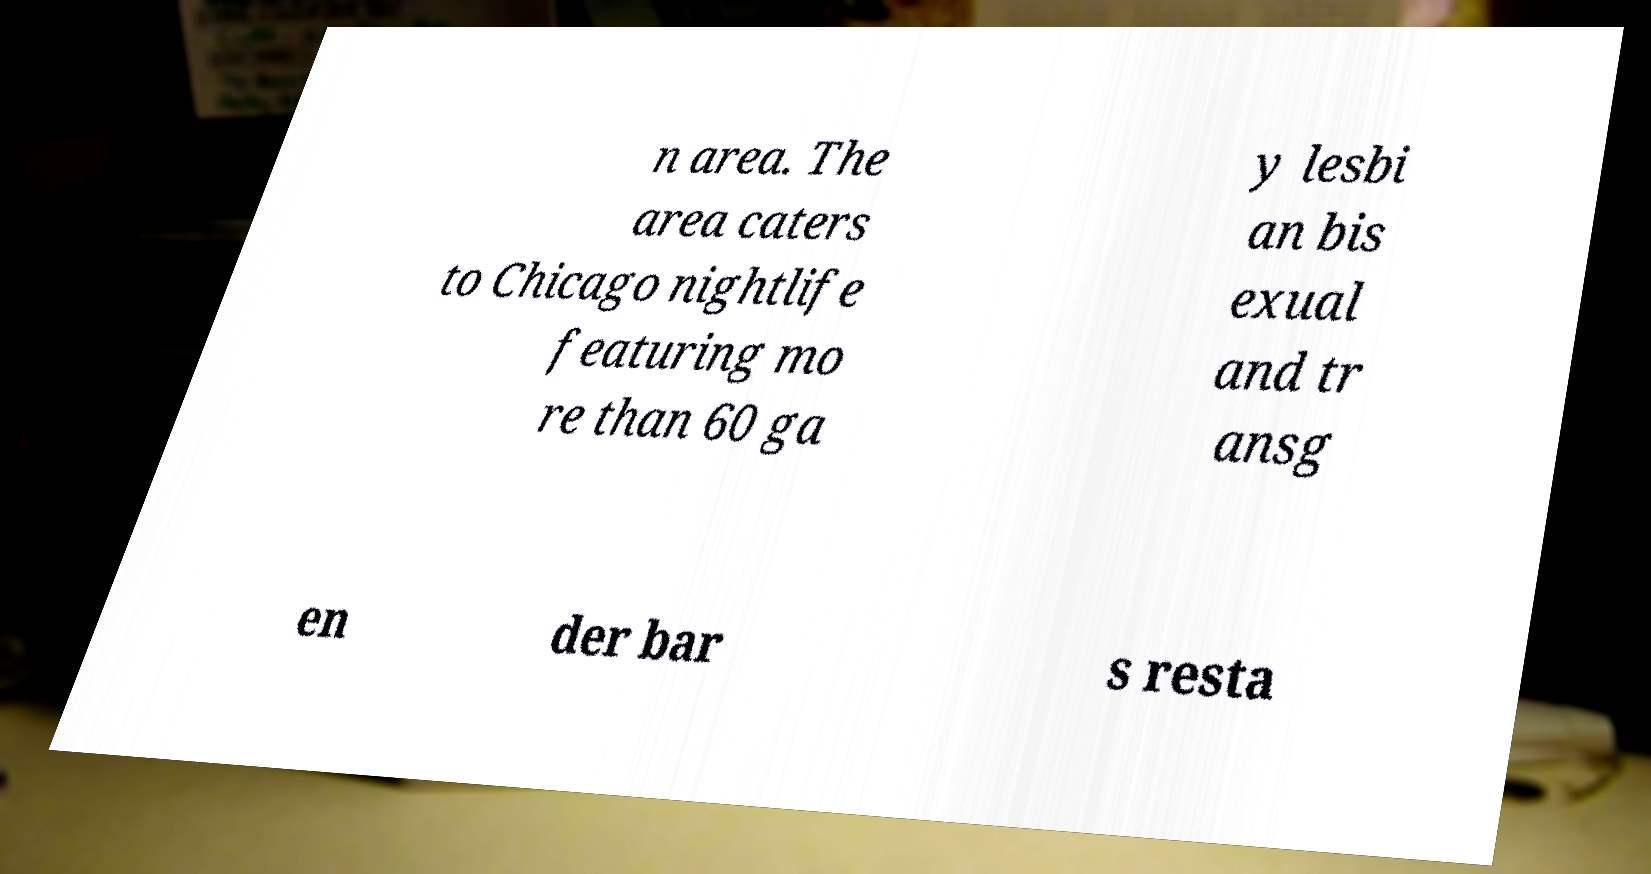There's text embedded in this image that I need extracted. Can you transcribe it verbatim? n area. The area caters to Chicago nightlife featuring mo re than 60 ga y lesbi an bis exual and tr ansg en der bar s resta 